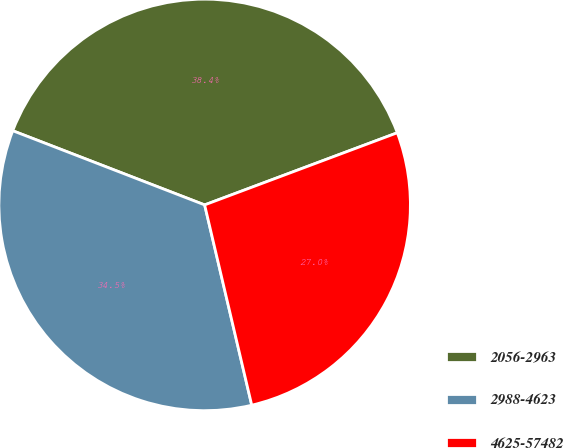Convert chart. <chart><loc_0><loc_0><loc_500><loc_500><pie_chart><fcel>2056-2963<fcel>2988-4623<fcel>4625-57482<nl><fcel>38.43%<fcel>34.55%<fcel>27.03%<nl></chart> 